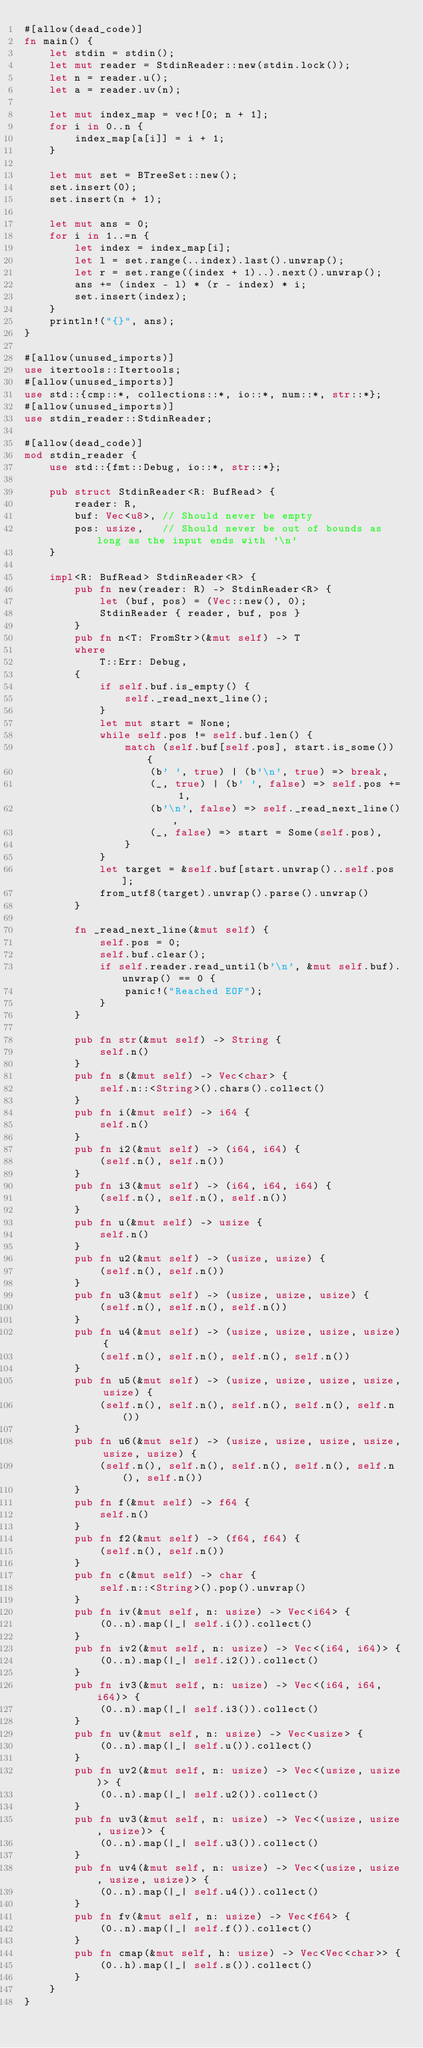Convert code to text. <code><loc_0><loc_0><loc_500><loc_500><_Rust_>#[allow(dead_code)]
fn main() {
    let stdin = stdin();
    let mut reader = StdinReader::new(stdin.lock());
    let n = reader.u();
    let a = reader.uv(n);

    let mut index_map = vec![0; n + 1];
    for i in 0..n {
        index_map[a[i]] = i + 1;
    }

    let mut set = BTreeSet::new();
    set.insert(0);
    set.insert(n + 1);

    let mut ans = 0;
    for i in 1..=n {
        let index = index_map[i];
        let l = set.range(..index).last().unwrap();
        let r = set.range((index + 1)..).next().unwrap();
        ans += (index - l) * (r - index) * i;
        set.insert(index);
    }
    println!("{}", ans);
}

#[allow(unused_imports)]
use itertools::Itertools;
#[allow(unused_imports)]
use std::{cmp::*, collections::*, io::*, num::*, str::*};
#[allow(unused_imports)]
use stdin_reader::StdinReader;

#[allow(dead_code)]
mod stdin_reader {
    use std::{fmt::Debug, io::*, str::*};

    pub struct StdinReader<R: BufRead> {
        reader: R,
        buf: Vec<u8>, // Should never be empty
        pos: usize,   // Should never be out of bounds as long as the input ends with '\n'
    }

    impl<R: BufRead> StdinReader<R> {
        pub fn new(reader: R) -> StdinReader<R> {
            let (buf, pos) = (Vec::new(), 0);
            StdinReader { reader, buf, pos }
        }
        pub fn n<T: FromStr>(&mut self) -> T
        where
            T::Err: Debug,
        {
            if self.buf.is_empty() {
                self._read_next_line();
            }
            let mut start = None;
            while self.pos != self.buf.len() {
                match (self.buf[self.pos], start.is_some()) {
                    (b' ', true) | (b'\n', true) => break,
                    (_, true) | (b' ', false) => self.pos += 1,
                    (b'\n', false) => self._read_next_line(),
                    (_, false) => start = Some(self.pos),
                }
            }
            let target = &self.buf[start.unwrap()..self.pos];
            from_utf8(target).unwrap().parse().unwrap()
        }

        fn _read_next_line(&mut self) {
            self.pos = 0;
            self.buf.clear();
            if self.reader.read_until(b'\n', &mut self.buf).unwrap() == 0 {
                panic!("Reached EOF");
            }
        }

        pub fn str(&mut self) -> String {
            self.n()
        }
        pub fn s(&mut self) -> Vec<char> {
            self.n::<String>().chars().collect()
        }
        pub fn i(&mut self) -> i64 {
            self.n()
        }
        pub fn i2(&mut self) -> (i64, i64) {
            (self.n(), self.n())
        }
        pub fn i3(&mut self) -> (i64, i64, i64) {
            (self.n(), self.n(), self.n())
        }
        pub fn u(&mut self) -> usize {
            self.n()
        }
        pub fn u2(&mut self) -> (usize, usize) {
            (self.n(), self.n())
        }
        pub fn u3(&mut self) -> (usize, usize, usize) {
            (self.n(), self.n(), self.n())
        }
        pub fn u4(&mut self) -> (usize, usize, usize, usize) {
            (self.n(), self.n(), self.n(), self.n())
        }
        pub fn u5(&mut self) -> (usize, usize, usize, usize, usize) {
            (self.n(), self.n(), self.n(), self.n(), self.n())
        }
        pub fn u6(&mut self) -> (usize, usize, usize, usize, usize, usize) {
            (self.n(), self.n(), self.n(), self.n(), self.n(), self.n())
        }
        pub fn f(&mut self) -> f64 {
            self.n()
        }
        pub fn f2(&mut self) -> (f64, f64) {
            (self.n(), self.n())
        }
        pub fn c(&mut self) -> char {
            self.n::<String>().pop().unwrap()
        }
        pub fn iv(&mut self, n: usize) -> Vec<i64> {
            (0..n).map(|_| self.i()).collect()
        }
        pub fn iv2(&mut self, n: usize) -> Vec<(i64, i64)> {
            (0..n).map(|_| self.i2()).collect()
        }
        pub fn iv3(&mut self, n: usize) -> Vec<(i64, i64, i64)> {
            (0..n).map(|_| self.i3()).collect()
        }
        pub fn uv(&mut self, n: usize) -> Vec<usize> {
            (0..n).map(|_| self.u()).collect()
        }
        pub fn uv2(&mut self, n: usize) -> Vec<(usize, usize)> {
            (0..n).map(|_| self.u2()).collect()
        }
        pub fn uv3(&mut self, n: usize) -> Vec<(usize, usize, usize)> {
            (0..n).map(|_| self.u3()).collect()
        }
        pub fn uv4(&mut self, n: usize) -> Vec<(usize, usize, usize, usize)> {
            (0..n).map(|_| self.u4()).collect()
        }
        pub fn fv(&mut self, n: usize) -> Vec<f64> {
            (0..n).map(|_| self.f()).collect()
        }
        pub fn cmap(&mut self, h: usize) -> Vec<Vec<char>> {
            (0..h).map(|_| self.s()).collect()
        }
    }
}
</code> 